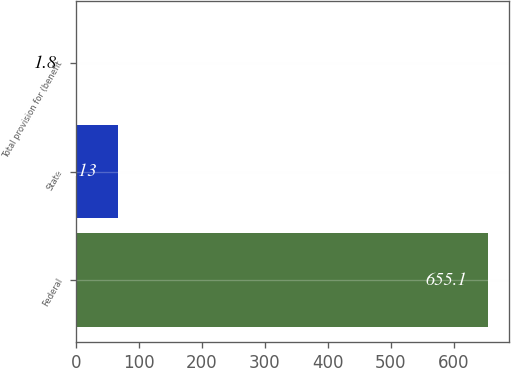Convert chart to OTSL. <chart><loc_0><loc_0><loc_500><loc_500><bar_chart><fcel>Federal<fcel>State<fcel>Total provision for (benefit<nl><fcel>655.1<fcel>67.13<fcel>1.8<nl></chart> 